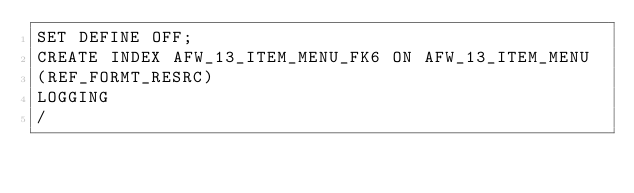<code> <loc_0><loc_0><loc_500><loc_500><_SQL_>SET DEFINE OFF;
CREATE INDEX AFW_13_ITEM_MENU_FK6 ON AFW_13_ITEM_MENU
(REF_FORMT_RESRC)
LOGGING
/
</code> 